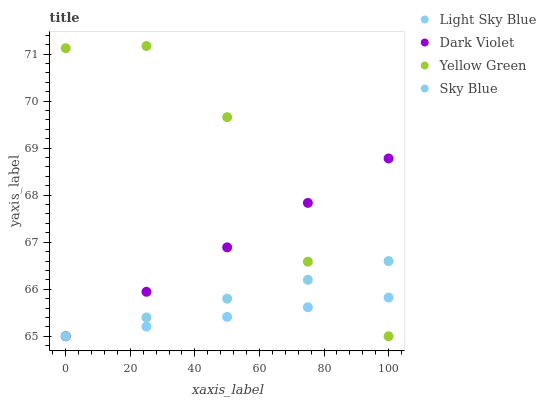Does Light Sky Blue have the minimum area under the curve?
Answer yes or no. Yes. Does Yellow Green have the maximum area under the curve?
Answer yes or no. Yes. Does Yellow Green have the minimum area under the curve?
Answer yes or no. No. Does Light Sky Blue have the maximum area under the curve?
Answer yes or no. No. Is Dark Violet the smoothest?
Answer yes or no. Yes. Is Yellow Green the roughest?
Answer yes or no. Yes. Is Light Sky Blue the smoothest?
Answer yes or no. No. Is Light Sky Blue the roughest?
Answer yes or no. No. Does Sky Blue have the lowest value?
Answer yes or no. Yes. Does Yellow Green have the highest value?
Answer yes or no. Yes. Does Light Sky Blue have the highest value?
Answer yes or no. No. Does Light Sky Blue intersect Dark Violet?
Answer yes or no. Yes. Is Light Sky Blue less than Dark Violet?
Answer yes or no. No. Is Light Sky Blue greater than Dark Violet?
Answer yes or no. No. 